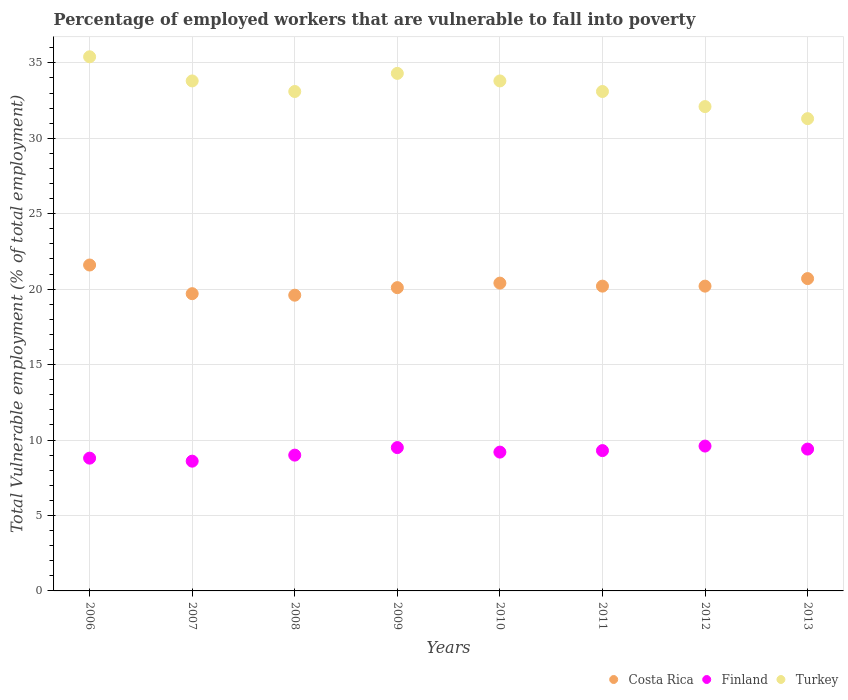How many different coloured dotlines are there?
Offer a very short reply. 3. Is the number of dotlines equal to the number of legend labels?
Provide a short and direct response. Yes. What is the percentage of employed workers who are vulnerable to fall into poverty in Costa Rica in 2008?
Your response must be concise. 19.6. Across all years, what is the maximum percentage of employed workers who are vulnerable to fall into poverty in Finland?
Your answer should be very brief. 9.6. Across all years, what is the minimum percentage of employed workers who are vulnerable to fall into poverty in Finland?
Ensure brevity in your answer.  8.6. What is the total percentage of employed workers who are vulnerable to fall into poverty in Turkey in the graph?
Provide a succinct answer. 266.9. What is the difference between the percentage of employed workers who are vulnerable to fall into poverty in Costa Rica in 2010 and that in 2013?
Provide a succinct answer. -0.3. What is the difference between the percentage of employed workers who are vulnerable to fall into poverty in Finland in 2010 and the percentage of employed workers who are vulnerable to fall into poverty in Costa Rica in 2008?
Ensure brevity in your answer.  -10.4. What is the average percentage of employed workers who are vulnerable to fall into poverty in Finland per year?
Offer a terse response. 9.18. In the year 2007, what is the difference between the percentage of employed workers who are vulnerable to fall into poverty in Turkey and percentage of employed workers who are vulnerable to fall into poverty in Costa Rica?
Ensure brevity in your answer.  14.1. In how many years, is the percentage of employed workers who are vulnerable to fall into poverty in Costa Rica greater than 8 %?
Provide a succinct answer. 8. What is the ratio of the percentage of employed workers who are vulnerable to fall into poverty in Costa Rica in 2007 to that in 2013?
Your answer should be compact. 0.95. Is the percentage of employed workers who are vulnerable to fall into poverty in Costa Rica in 2010 less than that in 2011?
Keep it short and to the point. No. Is the difference between the percentage of employed workers who are vulnerable to fall into poverty in Turkey in 2006 and 2013 greater than the difference between the percentage of employed workers who are vulnerable to fall into poverty in Costa Rica in 2006 and 2013?
Your answer should be very brief. Yes. What is the difference between the highest and the second highest percentage of employed workers who are vulnerable to fall into poverty in Costa Rica?
Offer a terse response. 0.9. What is the difference between the highest and the lowest percentage of employed workers who are vulnerable to fall into poverty in Turkey?
Provide a short and direct response. 4.1. In how many years, is the percentage of employed workers who are vulnerable to fall into poverty in Costa Rica greater than the average percentage of employed workers who are vulnerable to fall into poverty in Costa Rica taken over all years?
Your answer should be compact. 3. Is the percentage of employed workers who are vulnerable to fall into poverty in Finland strictly greater than the percentage of employed workers who are vulnerable to fall into poverty in Turkey over the years?
Keep it short and to the point. No. Is the percentage of employed workers who are vulnerable to fall into poverty in Turkey strictly less than the percentage of employed workers who are vulnerable to fall into poverty in Finland over the years?
Ensure brevity in your answer.  No. How many dotlines are there?
Keep it short and to the point. 3. How many years are there in the graph?
Provide a succinct answer. 8. What is the difference between two consecutive major ticks on the Y-axis?
Provide a succinct answer. 5. Does the graph contain any zero values?
Offer a very short reply. No. What is the title of the graph?
Provide a succinct answer. Percentage of employed workers that are vulnerable to fall into poverty. Does "Middle income" appear as one of the legend labels in the graph?
Make the answer very short. No. What is the label or title of the X-axis?
Your response must be concise. Years. What is the label or title of the Y-axis?
Make the answer very short. Total Vulnerable employment (% of total employment). What is the Total Vulnerable employment (% of total employment) in Costa Rica in 2006?
Give a very brief answer. 21.6. What is the Total Vulnerable employment (% of total employment) in Finland in 2006?
Your answer should be compact. 8.8. What is the Total Vulnerable employment (% of total employment) in Turkey in 2006?
Make the answer very short. 35.4. What is the Total Vulnerable employment (% of total employment) of Costa Rica in 2007?
Ensure brevity in your answer.  19.7. What is the Total Vulnerable employment (% of total employment) in Finland in 2007?
Provide a succinct answer. 8.6. What is the Total Vulnerable employment (% of total employment) of Turkey in 2007?
Your answer should be very brief. 33.8. What is the Total Vulnerable employment (% of total employment) of Costa Rica in 2008?
Give a very brief answer. 19.6. What is the Total Vulnerable employment (% of total employment) in Turkey in 2008?
Your response must be concise. 33.1. What is the Total Vulnerable employment (% of total employment) in Costa Rica in 2009?
Provide a short and direct response. 20.1. What is the Total Vulnerable employment (% of total employment) in Finland in 2009?
Offer a very short reply. 9.5. What is the Total Vulnerable employment (% of total employment) of Turkey in 2009?
Keep it short and to the point. 34.3. What is the Total Vulnerable employment (% of total employment) in Costa Rica in 2010?
Your answer should be compact. 20.4. What is the Total Vulnerable employment (% of total employment) in Finland in 2010?
Your answer should be compact. 9.2. What is the Total Vulnerable employment (% of total employment) in Turkey in 2010?
Make the answer very short. 33.8. What is the Total Vulnerable employment (% of total employment) in Costa Rica in 2011?
Provide a short and direct response. 20.2. What is the Total Vulnerable employment (% of total employment) in Finland in 2011?
Make the answer very short. 9.3. What is the Total Vulnerable employment (% of total employment) of Turkey in 2011?
Give a very brief answer. 33.1. What is the Total Vulnerable employment (% of total employment) in Costa Rica in 2012?
Provide a short and direct response. 20.2. What is the Total Vulnerable employment (% of total employment) in Finland in 2012?
Your answer should be very brief. 9.6. What is the Total Vulnerable employment (% of total employment) in Turkey in 2012?
Ensure brevity in your answer.  32.1. What is the Total Vulnerable employment (% of total employment) in Costa Rica in 2013?
Provide a short and direct response. 20.7. What is the Total Vulnerable employment (% of total employment) of Finland in 2013?
Your answer should be very brief. 9.4. What is the Total Vulnerable employment (% of total employment) of Turkey in 2013?
Keep it short and to the point. 31.3. Across all years, what is the maximum Total Vulnerable employment (% of total employment) of Costa Rica?
Keep it short and to the point. 21.6. Across all years, what is the maximum Total Vulnerable employment (% of total employment) of Finland?
Give a very brief answer. 9.6. Across all years, what is the maximum Total Vulnerable employment (% of total employment) of Turkey?
Provide a short and direct response. 35.4. Across all years, what is the minimum Total Vulnerable employment (% of total employment) in Costa Rica?
Provide a succinct answer. 19.6. Across all years, what is the minimum Total Vulnerable employment (% of total employment) of Finland?
Provide a succinct answer. 8.6. Across all years, what is the minimum Total Vulnerable employment (% of total employment) in Turkey?
Provide a short and direct response. 31.3. What is the total Total Vulnerable employment (% of total employment) of Costa Rica in the graph?
Offer a terse response. 162.5. What is the total Total Vulnerable employment (% of total employment) in Finland in the graph?
Provide a succinct answer. 73.4. What is the total Total Vulnerable employment (% of total employment) in Turkey in the graph?
Your answer should be compact. 266.9. What is the difference between the Total Vulnerable employment (% of total employment) of Costa Rica in 2006 and that in 2007?
Offer a very short reply. 1.9. What is the difference between the Total Vulnerable employment (% of total employment) in Finland in 2006 and that in 2007?
Your answer should be compact. 0.2. What is the difference between the Total Vulnerable employment (% of total employment) in Turkey in 2006 and that in 2007?
Your response must be concise. 1.6. What is the difference between the Total Vulnerable employment (% of total employment) in Costa Rica in 2006 and that in 2008?
Your answer should be compact. 2. What is the difference between the Total Vulnerable employment (% of total employment) of Finland in 2006 and that in 2008?
Your response must be concise. -0.2. What is the difference between the Total Vulnerable employment (% of total employment) of Turkey in 2006 and that in 2008?
Your answer should be compact. 2.3. What is the difference between the Total Vulnerable employment (% of total employment) in Costa Rica in 2006 and that in 2009?
Keep it short and to the point. 1.5. What is the difference between the Total Vulnerable employment (% of total employment) of Finland in 2006 and that in 2009?
Provide a short and direct response. -0.7. What is the difference between the Total Vulnerable employment (% of total employment) in Turkey in 2006 and that in 2009?
Offer a very short reply. 1.1. What is the difference between the Total Vulnerable employment (% of total employment) in Costa Rica in 2006 and that in 2010?
Your answer should be compact. 1.2. What is the difference between the Total Vulnerable employment (% of total employment) in Turkey in 2006 and that in 2010?
Ensure brevity in your answer.  1.6. What is the difference between the Total Vulnerable employment (% of total employment) in Turkey in 2006 and that in 2012?
Ensure brevity in your answer.  3.3. What is the difference between the Total Vulnerable employment (% of total employment) in Costa Rica in 2006 and that in 2013?
Make the answer very short. 0.9. What is the difference between the Total Vulnerable employment (% of total employment) of Costa Rica in 2007 and that in 2008?
Make the answer very short. 0.1. What is the difference between the Total Vulnerable employment (% of total employment) in Finland in 2007 and that in 2008?
Provide a short and direct response. -0.4. What is the difference between the Total Vulnerable employment (% of total employment) in Turkey in 2007 and that in 2008?
Ensure brevity in your answer.  0.7. What is the difference between the Total Vulnerable employment (% of total employment) of Finland in 2007 and that in 2009?
Ensure brevity in your answer.  -0.9. What is the difference between the Total Vulnerable employment (% of total employment) of Turkey in 2007 and that in 2009?
Your answer should be very brief. -0.5. What is the difference between the Total Vulnerable employment (% of total employment) in Finland in 2007 and that in 2010?
Your answer should be very brief. -0.6. What is the difference between the Total Vulnerable employment (% of total employment) in Turkey in 2007 and that in 2010?
Keep it short and to the point. 0. What is the difference between the Total Vulnerable employment (% of total employment) of Finland in 2007 and that in 2011?
Ensure brevity in your answer.  -0.7. What is the difference between the Total Vulnerable employment (% of total employment) of Costa Rica in 2007 and that in 2012?
Provide a short and direct response. -0.5. What is the difference between the Total Vulnerable employment (% of total employment) of Finland in 2007 and that in 2012?
Keep it short and to the point. -1. What is the difference between the Total Vulnerable employment (% of total employment) of Turkey in 2008 and that in 2010?
Provide a succinct answer. -0.7. What is the difference between the Total Vulnerable employment (% of total employment) of Costa Rica in 2008 and that in 2011?
Give a very brief answer. -0.6. What is the difference between the Total Vulnerable employment (% of total employment) of Finland in 2008 and that in 2011?
Offer a very short reply. -0.3. What is the difference between the Total Vulnerable employment (% of total employment) of Costa Rica in 2008 and that in 2012?
Give a very brief answer. -0.6. What is the difference between the Total Vulnerable employment (% of total employment) of Finland in 2008 and that in 2012?
Provide a succinct answer. -0.6. What is the difference between the Total Vulnerable employment (% of total employment) of Turkey in 2008 and that in 2012?
Provide a short and direct response. 1. What is the difference between the Total Vulnerable employment (% of total employment) in Costa Rica in 2008 and that in 2013?
Give a very brief answer. -1.1. What is the difference between the Total Vulnerable employment (% of total employment) in Turkey in 2008 and that in 2013?
Offer a terse response. 1.8. What is the difference between the Total Vulnerable employment (% of total employment) of Costa Rica in 2009 and that in 2012?
Ensure brevity in your answer.  -0.1. What is the difference between the Total Vulnerable employment (% of total employment) in Finland in 2009 and that in 2012?
Offer a very short reply. -0.1. What is the difference between the Total Vulnerable employment (% of total employment) in Turkey in 2009 and that in 2012?
Offer a terse response. 2.2. What is the difference between the Total Vulnerable employment (% of total employment) in Finland in 2010 and that in 2011?
Offer a very short reply. -0.1. What is the difference between the Total Vulnerable employment (% of total employment) in Finland in 2010 and that in 2012?
Provide a short and direct response. -0.4. What is the difference between the Total Vulnerable employment (% of total employment) in Turkey in 2010 and that in 2012?
Provide a succinct answer. 1.7. What is the difference between the Total Vulnerable employment (% of total employment) in Costa Rica in 2010 and that in 2013?
Give a very brief answer. -0.3. What is the difference between the Total Vulnerable employment (% of total employment) of Turkey in 2010 and that in 2013?
Provide a succinct answer. 2.5. What is the difference between the Total Vulnerable employment (% of total employment) of Turkey in 2011 and that in 2012?
Offer a very short reply. 1. What is the difference between the Total Vulnerable employment (% of total employment) in Costa Rica in 2011 and that in 2013?
Make the answer very short. -0.5. What is the difference between the Total Vulnerable employment (% of total employment) in Turkey in 2011 and that in 2013?
Offer a terse response. 1.8. What is the difference between the Total Vulnerable employment (% of total employment) of Costa Rica in 2012 and that in 2013?
Give a very brief answer. -0.5. What is the difference between the Total Vulnerable employment (% of total employment) of Finland in 2012 and that in 2013?
Your answer should be very brief. 0.2. What is the difference between the Total Vulnerable employment (% of total employment) of Turkey in 2012 and that in 2013?
Provide a short and direct response. 0.8. What is the difference between the Total Vulnerable employment (% of total employment) in Costa Rica in 2006 and the Total Vulnerable employment (% of total employment) in Finland in 2007?
Provide a succinct answer. 13. What is the difference between the Total Vulnerable employment (% of total employment) of Costa Rica in 2006 and the Total Vulnerable employment (% of total employment) of Turkey in 2007?
Ensure brevity in your answer.  -12.2. What is the difference between the Total Vulnerable employment (% of total employment) of Costa Rica in 2006 and the Total Vulnerable employment (% of total employment) of Finland in 2008?
Offer a very short reply. 12.6. What is the difference between the Total Vulnerable employment (% of total employment) of Finland in 2006 and the Total Vulnerable employment (% of total employment) of Turkey in 2008?
Offer a very short reply. -24.3. What is the difference between the Total Vulnerable employment (% of total employment) of Costa Rica in 2006 and the Total Vulnerable employment (% of total employment) of Finland in 2009?
Give a very brief answer. 12.1. What is the difference between the Total Vulnerable employment (% of total employment) in Costa Rica in 2006 and the Total Vulnerable employment (% of total employment) in Turkey in 2009?
Offer a terse response. -12.7. What is the difference between the Total Vulnerable employment (% of total employment) of Finland in 2006 and the Total Vulnerable employment (% of total employment) of Turkey in 2009?
Provide a short and direct response. -25.5. What is the difference between the Total Vulnerable employment (% of total employment) of Costa Rica in 2006 and the Total Vulnerable employment (% of total employment) of Turkey in 2010?
Provide a short and direct response. -12.2. What is the difference between the Total Vulnerable employment (% of total employment) of Finland in 2006 and the Total Vulnerable employment (% of total employment) of Turkey in 2011?
Provide a succinct answer. -24.3. What is the difference between the Total Vulnerable employment (% of total employment) of Costa Rica in 2006 and the Total Vulnerable employment (% of total employment) of Turkey in 2012?
Your answer should be compact. -10.5. What is the difference between the Total Vulnerable employment (% of total employment) of Finland in 2006 and the Total Vulnerable employment (% of total employment) of Turkey in 2012?
Provide a succinct answer. -23.3. What is the difference between the Total Vulnerable employment (% of total employment) in Costa Rica in 2006 and the Total Vulnerable employment (% of total employment) in Finland in 2013?
Your answer should be compact. 12.2. What is the difference between the Total Vulnerable employment (% of total employment) in Costa Rica in 2006 and the Total Vulnerable employment (% of total employment) in Turkey in 2013?
Offer a terse response. -9.7. What is the difference between the Total Vulnerable employment (% of total employment) of Finland in 2006 and the Total Vulnerable employment (% of total employment) of Turkey in 2013?
Your response must be concise. -22.5. What is the difference between the Total Vulnerable employment (% of total employment) of Finland in 2007 and the Total Vulnerable employment (% of total employment) of Turkey in 2008?
Provide a short and direct response. -24.5. What is the difference between the Total Vulnerable employment (% of total employment) of Costa Rica in 2007 and the Total Vulnerable employment (% of total employment) of Finland in 2009?
Offer a very short reply. 10.2. What is the difference between the Total Vulnerable employment (% of total employment) of Costa Rica in 2007 and the Total Vulnerable employment (% of total employment) of Turkey in 2009?
Give a very brief answer. -14.6. What is the difference between the Total Vulnerable employment (% of total employment) in Finland in 2007 and the Total Vulnerable employment (% of total employment) in Turkey in 2009?
Keep it short and to the point. -25.7. What is the difference between the Total Vulnerable employment (% of total employment) of Costa Rica in 2007 and the Total Vulnerable employment (% of total employment) of Turkey in 2010?
Provide a short and direct response. -14.1. What is the difference between the Total Vulnerable employment (% of total employment) in Finland in 2007 and the Total Vulnerable employment (% of total employment) in Turkey in 2010?
Offer a very short reply. -25.2. What is the difference between the Total Vulnerable employment (% of total employment) of Costa Rica in 2007 and the Total Vulnerable employment (% of total employment) of Turkey in 2011?
Ensure brevity in your answer.  -13.4. What is the difference between the Total Vulnerable employment (% of total employment) in Finland in 2007 and the Total Vulnerable employment (% of total employment) in Turkey in 2011?
Ensure brevity in your answer.  -24.5. What is the difference between the Total Vulnerable employment (% of total employment) of Finland in 2007 and the Total Vulnerable employment (% of total employment) of Turkey in 2012?
Your answer should be very brief. -23.5. What is the difference between the Total Vulnerable employment (% of total employment) in Costa Rica in 2007 and the Total Vulnerable employment (% of total employment) in Finland in 2013?
Your answer should be compact. 10.3. What is the difference between the Total Vulnerable employment (% of total employment) in Finland in 2007 and the Total Vulnerable employment (% of total employment) in Turkey in 2013?
Offer a terse response. -22.7. What is the difference between the Total Vulnerable employment (% of total employment) in Costa Rica in 2008 and the Total Vulnerable employment (% of total employment) in Finland in 2009?
Your response must be concise. 10.1. What is the difference between the Total Vulnerable employment (% of total employment) in Costa Rica in 2008 and the Total Vulnerable employment (% of total employment) in Turkey in 2009?
Offer a very short reply. -14.7. What is the difference between the Total Vulnerable employment (% of total employment) of Finland in 2008 and the Total Vulnerable employment (% of total employment) of Turkey in 2009?
Ensure brevity in your answer.  -25.3. What is the difference between the Total Vulnerable employment (% of total employment) in Costa Rica in 2008 and the Total Vulnerable employment (% of total employment) in Turkey in 2010?
Your answer should be compact. -14.2. What is the difference between the Total Vulnerable employment (% of total employment) in Finland in 2008 and the Total Vulnerable employment (% of total employment) in Turkey in 2010?
Make the answer very short. -24.8. What is the difference between the Total Vulnerable employment (% of total employment) of Costa Rica in 2008 and the Total Vulnerable employment (% of total employment) of Finland in 2011?
Offer a very short reply. 10.3. What is the difference between the Total Vulnerable employment (% of total employment) of Costa Rica in 2008 and the Total Vulnerable employment (% of total employment) of Turkey in 2011?
Make the answer very short. -13.5. What is the difference between the Total Vulnerable employment (% of total employment) of Finland in 2008 and the Total Vulnerable employment (% of total employment) of Turkey in 2011?
Give a very brief answer. -24.1. What is the difference between the Total Vulnerable employment (% of total employment) in Costa Rica in 2008 and the Total Vulnerable employment (% of total employment) in Finland in 2012?
Your answer should be very brief. 10. What is the difference between the Total Vulnerable employment (% of total employment) in Finland in 2008 and the Total Vulnerable employment (% of total employment) in Turkey in 2012?
Ensure brevity in your answer.  -23.1. What is the difference between the Total Vulnerable employment (% of total employment) in Costa Rica in 2008 and the Total Vulnerable employment (% of total employment) in Finland in 2013?
Make the answer very short. 10.2. What is the difference between the Total Vulnerable employment (% of total employment) in Costa Rica in 2008 and the Total Vulnerable employment (% of total employment) in Turkey in 2013?
Your response must be concise. -11.7. What is the difference between the Total Vulnerable employment (% of total employment) of Finland in 2008 and the Total Vulnerable employment (% of total employment) of Turkey in 2013?
Offer a very short reply. -22.3. What is the difference between the Total Vulnerable employment (% of total employment) of Costa Rica in 2009 and the Total Vulnerable employment (% of total employment) of Turkey in 2010?
Ensure brevity in your answer.  -13.7. What is the difference between the Total Vulnerable employment (% of total employment) of Finland in 2009 and the Total Vulnerable employment (% of total employment) of Turkey in 2010?
Provide a succinct answer. -24.3. What is the difference between the Total Vulnerable employment (% of total employment) in Costa Rica in 2009 and the Total Vulnerable employment (% of total employment) in Turkey in 2011?
Your answer should be compact. -13. What is the difference between the Total Vulnerable employment (% of total employment) in Finland in 2009 and the Total Vulnerable employment (% of total employment) in Turkey in 2011?
Provide a short and direct response. -23.6. What is the difference between the Total Vulnerable employment (% of total employment) of Costa Rica in 2009 and the Total Vulnerable employment (% of total employment) of Finland in 2012?
Provide a succinct answer. 10.5. What is the difference between the Total Vulnerable employment (% of total employment) in Finland in 2009 and the Total Vulnerable employment (% of total employment) in Turkey in 2012?
Offer a terse response. -22.6. What is the difference between the Total Vulnerable employment (% of total employment) in Costa Rica in 2009 and the Total Vulnerable employment (% of total employment) in Finland in 2013?
Offer a terse response. 10.7. What is the difference between the Total Vulnerable employment (% of total employment) of Finland in 2009 and the Total Vulnerable employment (% of total employment) of Turkey in 2013?
Make the answer very short. -21.8. What is the difference between the Total Vulnerable employment (% of total employment) in Finland in 2010 and the Total Vulnerable employment (% of total employment) in Turkey in 2011?
Your response must be concise. -23.9. What is the difference between the Total Vulnerable employment (% of total employment) in Costa Rica in 2010 and the Total Vulnerable employment (% of total employment) in Finland in 2012?
Offer a terse response. 10.8. What is the difference between the Total Vulnerable employment (% of total employment) of Costa Rica in 2010 and the Total Vulnerable employment (% of total employment) of Turkey in 2012?
Your answer should be compact. -11.7. What is the difference between the Total Vulnerable employment (% of total employment) in Finland in 2010 and the Total Vulnerable employment (% of total employment) in Turkey in 2012?
Your answer should be very brief. -22.9. What is the difference between the Total Vulnerable employment (% of total employment) in Costa Rica in 2010 and the Total Vulnerable employment (% of total employment) in Turkey in 2013?
Make the answer very short. -10.9. What is the difference between the Total Vulnerable employment (% of total employment) in Finland in 2010 and the Total Vulnerable employment (% of total employment) in Turkey in 2013?
Ensure brevity in your answer.  -22.1. What is the difference between the Total Vulnerable employment (% of total employment) of Costa Rica in 2011 and the Total Vulnerable employment (% of total employment) of Turkey in 2012?
Offer a very short reply. -11.9. What is the difference between the Total Vulnerable employment (% of total employment) of Finland in 2011 and the Total Vulnerable employment (% of total employment) of Turkey in 2012?
Provide a short and direct response. -22.8. What is the difference between the Total Vulnerable employment (% of total employment) of Costa Rica in 2011 and the Total Vulnerable employment (% of total employment) of Finland in 2013?
Your answer should be very brief. 10.8. What is the difference between the Total Vulnerable employment (% of total employment) of Costa Rica in 2011 and the Total Vulnerable employment (% of total employment) of Turkey in 2013?
Offer a terse response. -11.1. What is the difference between the Total Vulnerable employment (% of total employment) of Finland in 2012 and the Total Vulnerable employment (% of total employment) of Turkey in 2013?
Offer a very short reply. -21.7. What is the average Total Vulnerable employment (% of total employment) of Costa Rica per year?
Your response must be concise. 20.31. What is the average Total Vulnerable employment (% of total employment) in Finland per year?
Provide a short and direct response. 9.18. What is the average Total Vulnerable employment (% of total employment) of Turkey per year?
Provide a succinct answer. 33.36. In the year 2006, what is the difference between the Total Vulnerable employment (% of total employment) in Costa Rica and Total Vulnerable employment (% of total employment) in Turkey?
Offer a very short reply. -13.8. In the year 2006, what is the difference between the Total Vulnerable employment (% of total employment) in Finland and Total Vulnerable employment (% of total employment) in Turkey?
Provide a short and direct response. -26.6. In the year 2007, what is the difference between the Total Vulnerable employment (% of total employment) of Costa Rica and Total Vulnerable employment (% of total employment) of Turkey?
Offer a terse response. -14.1. In the year 2007, what is the difference between the Total Vulnerable employment (% of total employment) in Finland and Total Vulnerable employment (% of total employment) in Turkey?
Your answer should be compact. -25.2. In the year 2008, what is the difference between the Total Vulnerable employment (% of total employment) in Costa Rica and Total Vulnerable employment (% of total employment) in Turkey?
Offer a terse response. -13.5. In the year 2008, what is the difference between the Total Vulnerable employment (% of total employment) of Finland and Total Vulnerable employment (% of total employment) of Turkey?
Offer a very short reply. -24.1. In the year 2009, what is the difference between the Total Vulnerable employment (% of total employment) of Costa Rica and Total Vulnerable employment (% of total employment) of Finland?
Ensure brevity in your answer.  10.6. In the year 2009, what is the difference between the Total Vulnerable employment (% of total employment) of Finland and Total Vulnerable employment (% of total employment) of Turkey?
Your answer should be very brief. -24.8. In the year 2010, what is the difference between the Total Vulnerable employment (% of total employment) in Finland and Total Vulnerable employment (% of total employment) in Turkey?
Ensure brevity in your answer.  -24.6. In the year 2011, what is the difference between the Total Vulnerable employment (% of total employment) in Costa Rica and Total Vulnerable employment (% of total employment) in Finland?
Make the answer very short. 10.9. In the year 2011, what is the difference between the Total Vulnerable employment (% of total employment) in Finland and Total Vulnerable employment (% of total employment) in Turkey?
Provide a succinct answer. -23.8. In the year 2012, what is the difference between the Total Vulnerable employment (% of total employment) of Costa Rica and Total Vulnerable employment (% of total employment) of Finland?
Your answer should be compact. 10.6. In the year 2012, what is the difference between the Total Vulnerable employment (% of total employment) of Costa Rica and Total Vulnerable employment (% of total employment) of Turkey?
Your response must be concise. -11.9. In the year 2012, what is the difference between the Total Vulnerable employment (% of total employment) in Finland and Total Vulnerable employment (% of total employment) in Turkey?
Offer a very short reply. -22.5. In the year 2013, what is the difference between the Total Vulnerable employment (% of total employment) in Costa Rica and Total Vulnerable employment (% of total employment) in Turkey?
Your answer should be very brief. -10.6. In the year 2013, what is the difference between the Total Vulnerable employment (% of total employment) of Finland and Total Vulnerable employment (% of total employment) of Turkey?
Offer a terse response. -21.9. What is the ratio of the Total Vulnerable employment (% of total employment) in Costa Rica in 2006 to that in 2007?
Your response must be concise. 1.1. What is the ratio of the Total Vulnerable employment (% of total employment) of Finland in 2006 to that in 2007?
Ensure brevity in your answer.  1.02. What is the ratio of the Total Vulnerable employment (% of total employment) of Turkey in 2006 to that in 2007?
Give a very brief answer. 1.05. What is the ratio of the Total Vulnerable employment (% of total employment) of Costa Rica in 2006 to that in 2008?
Your answer should be compact. 1.1. What is the ratio of the Total Vulnerable employment (% of total employment) in Finland in 2006 to that in 2008?
Your answer should be very brief. 0.98. What is the ratio of the Total Vulnerable employment (% of total employment) of Turkey in 2006 to that in 2008?
Provide a succinct answer. 1.07. What is the ratio of the Total Vulnerable employment (% of total employment) of Costa Rica in 2006 to that in 2009?
Provide a succinct answer. 1.07. What is the ratio of the Total Vulnerable employment (% of total employment) in Finland in 2006 to that in 2009?
Make the answer very short. 0.93. What is the ratio of the Total Vulnerable employment (% of total employment) in Turkey in 2006 to that in 2009?
Provide a short and direct response. 1.03. What is the ratio of the Total Vulnerable employment (% of total employment) in Costa Rica in 2006 to that in 2010?
Your answer should be very brief. 1.06. What is the ratio of the Total Vulnerable employment (% of total employment) in Finland in 2006 to that in 2010?
Give a very brief answer. 0.96. What is the ratio of the Total Vulnerable employment (% of total employment) in Turkey in 2006 to that in 2010?
Keep it short and to the point. 1.05. What is the ratio of the Total Vulnerable employment (% of total employment) of Costa Rica in 2006 to that in 2011?
Make the answer very short. 1.07. What is the ratio of the Total Vulnerable employment (% of total employment) in Finland in 2006 to that in 2011?
Offer a terse response. 0.95. What is the ratio of the Total Vulnerable employment (% of total employment) in Turkey in 2006 to that in 2011?
Provide a short and direct response. 1.07. What is the ratio of the Total Vulnerable employment (% of total employment) of Costa Rica in 2006 to that in 2012?
Offer a terse response. 1.07. What is the ratio of the Total Vulnerable employment (% of total employment) in Finland in 2006 to that in 2012?
Provide a succinct answer. 0.92. What is the ratio of the Total Vulnerable employment (% of total employment) in Turkey in 2006 to that in 2012?
Make the answer very short. 1.1. What is the ratio of the Total Vulnerable employment (% of total employment) of Costa Rica in 2006 to that in 2013?
Provide a short and direct response. 1.04. What is the ratio of the Total Vulnerable employment (% of total employment) in Finland in 2006 to that in 2013?
Your response must be concise. 0.94. What is the ratio of the Total Vulnerable employment (% of total employment) of Turkey in 2006 to that in 2013?
Offer a very short reply. 1.13. What is the ratio of the Total Vulnerable employment (% of total employment) in Finland in 2007 to that in 2008?
Your answer should be very brief. 0.96. What is the ratio of the Total Vulnerable employment (% of total employment) in Turkey in 2007 to that in 2008?
Give a very brief answer. 1.02. What is the ratio of the Total Vulnerable employment (% of total employment) in Costa Rica in 2007 to that in 2009?
Your response must be concise. 0.98. What is the ratio of the Total Vulnerable employment (% of total employment) of Finland in 2007 to that in 2009?
Ensure brevity in your answer.  0.91. What is the ratio of the Total Vulnerable employment (% of total employment) in Turkey in 2007 to that in 2009?
Provide a short and direct response. 0.99. What is the ratio of the Total Vulnerable employment (% of total employment) in Costa Rica in 2007 to that in 2010?
Your response must be concise. 0.97. What is the ratio of the Total Vulnerable employment (% of total employment) of Finland in 2007 to that in 2010?
Keep it short and to the point. 0.93. What is the ratio of the Total Vulnerable employment (% of total employment) of Costa Rica in 2007 to that in 2011?
Keep it short and to the point. 0.98. What is the ratio of the Total Vulnerable employment (% of total employment) in Finland in 2007 to that in 2011?
Offer a terse response. 0.92. What is the ratio of the Total Vulnerable employment (% of total employment) of Turkey in 2007 to that in 2011?
Provide a succinct answer. 1.02. What is the ratio of the Total Vulnerable employment (% of total employment) in Costa Rica in 2007 to that in 2012?
Your response must be concise. 0.98. What is the ratio of the Total Vulnerable employment (% of total employment) of Finland in 2007 to that in 2012?
Ensure brevity in your answer.  0.9. What is the ratio of the Total Vulnerable employment (% of total employment) in Turkey in 2007 to that in 2012?
Make the answer very short. 1.05. What is the ratio of the Total Vulnerable employment (% of total employment) of Costa Rica in 2007 to that in 2013?
Your response must be concise. 0.95. What is the ratio of the Total Vulnerable employment (% of total employment) in Finland in 2007 to that in 2013?
Make the answer very short. 0.91. What is the ratio of the Total Vulnerable employment (% of total employment) in Turkey in 2007 to that in 2013?
Ensure brevity in your answer.  1.08. What is the ratio of the Total Vulnerable employment (% of total employment) in Costa Rica in 2008 to that in 2009?
Provide a short and direct response. 0.98. What is the ratio of the Total Vulnerable employment (% of total employment) in Costa Rica in 2008 to that in 2010?
Make the answer very short. 0.96. What is the ratio of the Total Vulnerable employment (% of total employment) in Finland in 2008 to that in 2010?
Your answer should be very brief. 0.98. What is the ratio of the Total Vulnerable employment (% of total employment) of Turkey in 2008 to that in 2010?
Make the answer very short. 0.98. What is the ratio of the Total Vulnerable employment (% of total employment) of Costa Rica in 2008 to that in 2011?
Your answer should be compact. 0.97. What is the ratio of the Total Vulnerable employment (% of total employment) in Finland in 2008 to that in 2011?
Give a very brief answer. 0.97. What is the ratio of the Total Vulnerable employment (% of total employment) in Costa Rica in 2008 to that in 2012?
Provide a succinct answer. 0.97. What is the ratio of the Total Vulnerable employment (% of total employment) in Finland in 2008 to that in 2012?
Your answer should be very brief. 0.94. What is the ratio of the Total Vulnerable employment (% of total employment) in Turkey in 2008 to that in 2012?
Ensure brevity in your answer.  1.03. What is the ratio of the Total Vulnerable employment (% of total employment) in Costa Rica in 2008 to that in 2013?
Provide a short and direct response. 0.95. What is the ratio of the Total Vulnerable employment (% of total employment) of Finland in 2008 to that in 2013?
Your response must be concise. 0.96. What is the ratio of the Total Vulnerable employment (% of total employment) of Turkey in 2008 to that in 2013?
Give a very brief answer. 1.06. What is the ratio of the Total Vulnerable employment (% of total employment) in Costa Rica in 2009 to that in 2010?
Offer a very short reply. 0.99. What is the ratio of the Total Vulnerable employment (% of total employment) of Finland in 2009 to that in 2010?
Give a very brief answer. 1.03. What is the ratio of the Total Vulnerable employment (% of total employment) of Turkey in 2009 to that in 2010?
Provide a short and direct response. 1.01. What is the ratio of the Total Vulnerable employment (% of total employment) in Costa Rica in 2009 to that in 2011?
Keep it short and to the point. 0.99. What is the ratio of the Total Vulnerable employment (% of total employment) in Finland in 2009 to that in 2011?
Provide a succinct answer. 1.02. What is the ratio of the Total Vulnerable employment (% of total employment) of Turkey in 2009 to that in 2011?
Provide a short and direct response. 1.04. What is the ratio of the Total Vulnerable employment (% of total employment) in Costa Rica in 2009 to that in 2012?
Ensure brevity in your answer.  0.99. What is the ratio of the Total Vulnerable employment (% of total employment) of Finland in 2009 to that in 2012?
Offer a terse response. 0.99. What is the ratio of the Total Vulnerable employment (% of total employment) of Turkey in 2009 to that in 2012?
Your response must be concise. 1.07. What is the ratio of the Total Vulnerable employment (% of total employment) of Costa Rica in 2009 to that in 2013?
Provide a succinct answer. 0.97. What is the ratio of the Total Vulnerable employment (% of total employment) of Finland in 2009 to that in 2013?
Ensure brevity in your answer.  1.01. What is the ratio of the Total Vulnerable employment (% of total employment) of Turkey in 2009 to that in 2013?
Make the answer very short. 1.1. What is the ratio of the Total Vulnerable employment (% of total employment) in Costa Rica in 2010 to that in 2011?
Ensure brevity in your answer.  1.01. What is the ratio of the Total Vulnerable employment (% of total employment) of Finland in 2010 to that in 2011?
Provide a succinct answer. 0.99. What is the ratio of the Total Vulnerable employment (% of total employment) of Turkey in 2010 to that in 2011?
Offer a terse response. 1.02. What is the ratio of the Total Vulnerable employment (% of total employment) of Costa Rica in 2010 to that in 2012?
Give a very brief answer. 1.01. What is the ratio of the Total Vulnerable employment (% of total employment) in Finland in 2010 to that in 2012?
Make the answer very short. 0.96. What is the ratio of the Total Vulnerable employment (% of total employment) in Turkey in 2010 to that in 2012?
Offer a very short reply. 1.05. What is the ratio of the Total Vulnerable employment (% of total employment) in Costa Rica in 2010 to that in 2013?
Keep it short and to the point. 0.99. What is the ratio of the Total Vulnerable employment (% of total employment) of Finland in 2010 to that in 2013?
Offer a very short reply. 0.98. What is the ratio of the Total Vulnerable employment (% of total employment) of Turkey in 2010 to that in 2013?
Provide a short and direct response. 1.08. What is the ratio of the Total Vulnerable employment (% of total employment) of Finland in 2011 to that in 2012?
Ensure brevity in your answer.  0.97. What is the ratio of the Total Vulnerable employment (% of total employment) of Turkey in 2011 to that in 2012?
Make the answer very short. 1.03. What is the ratio of the Total Vulnerable employment (% of total employment) of Costa Rica in 2011 to that in 2013?
Give a very brief answer. 0.98. What is the ratio of the Total Vulnerable employment (% of total employment) of Turkey in 2011 to that in 2013?
Provide a short and direct response. 1.06. What is the ratio of the Total Vulnerable employment (% of total employment) of Costa Rica in 2012 to that in 2013?
Ensure brevity in your answer.  0.98. What is the ratio of the Total Vulnerable employment (% of total employment) of Finland in 2012 to that in 2013?
Provide a short and direct response. 1.02. What is the ratio of the Total Vulnerable employment (% of total employment) of Turkey in 2012 to that in 2013?
Keep it short and to the point. 1.03. What is the difference between the highest and the second highest Total Vulnerable employment (% of total employment) of Costa Rica?
Provide a short and direct response. 0.9. What is the difference between the highest and the second highest Total Vulnerable employment (% of total employment) in Turkey?
Offer a very short reply. 1.1. 